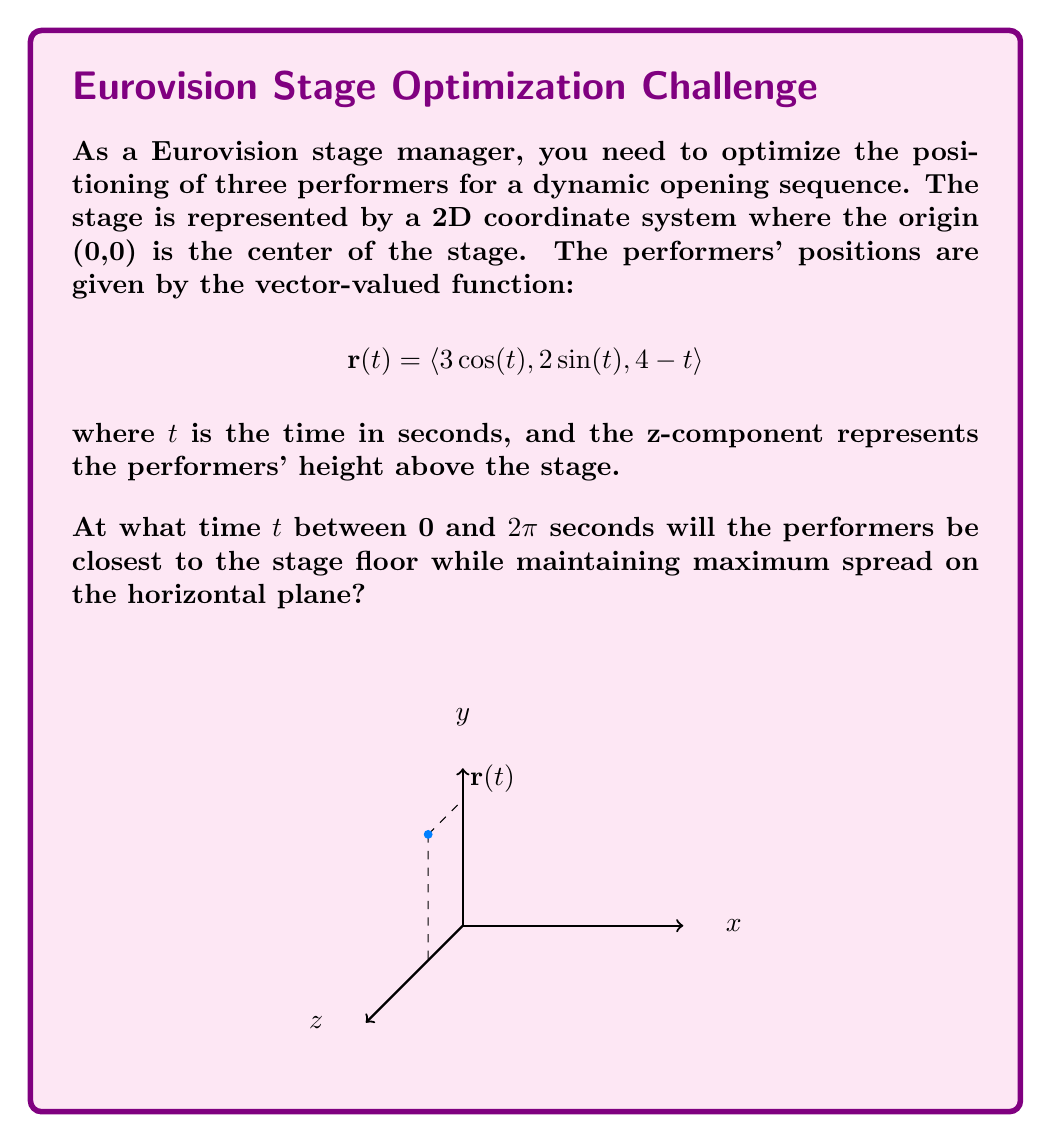Provide a solution to this math problem. Let's approach this step-by-step:

1) To find the maximum spread on the horizontal plane, we need to maximize the magnitude of the projection of $\mathbf{r}(t)$ onto the xy-plane.

2) The projection onto the xy-plane is given by:
   $$\mathbf{r}_{xy}(t) = \langle 3\cos(t), 2\sin(t), 0 \rangle$$

3) The magnitude of this projection is:
   $$|\mathbf{r}_{xy}(t)| = \sqrt{(3\cos(t))^2 + (2\sin(t))^2}$$

4) To maximize this, we can maximize its square:
   $$|\mathbf{r}_{xy}(t)|^2 = 9\cos^2(t) + 4\sin^2(t) = 9 - 5\sin^2(t)$$

5) This is maximized when $\sin^2(t)$ is minimized, which occurs when $t = 0, \pi, 2\pi, ...$

6) Now, we need to consider the height (z-component). The height is given by:
   $$z(t) = 4-t$$

7) Among the values $t = 0, \pi, 2\pi$ (within our range), the smallest height occurs when $t$ is largest, which is $2\pi$.

Therefore, the performers will be closest to the stage floor while maintaining maximum spread on the horizontal plane when $t = 2\pi$ seconds.
Answer: $2\pi$ seconds 